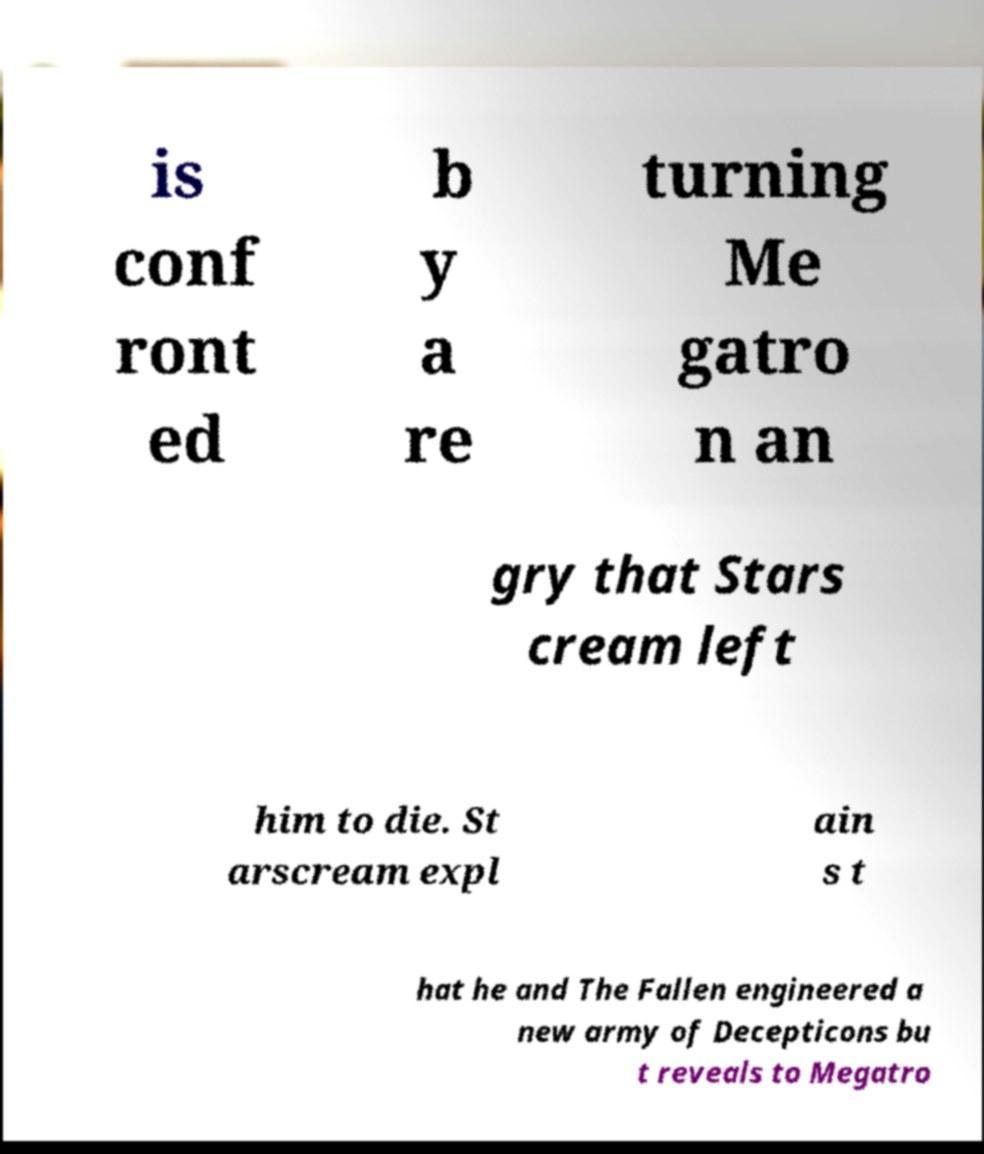Can you accurately transcribe the text from the provided image for me? is conf ront ed b y a re turning Me gatro n an gry that Stars cream left him to die. St arscream expl ain s t hat he and The Fallen engineered a new army of Decepticons bu t reveals to Megatro 